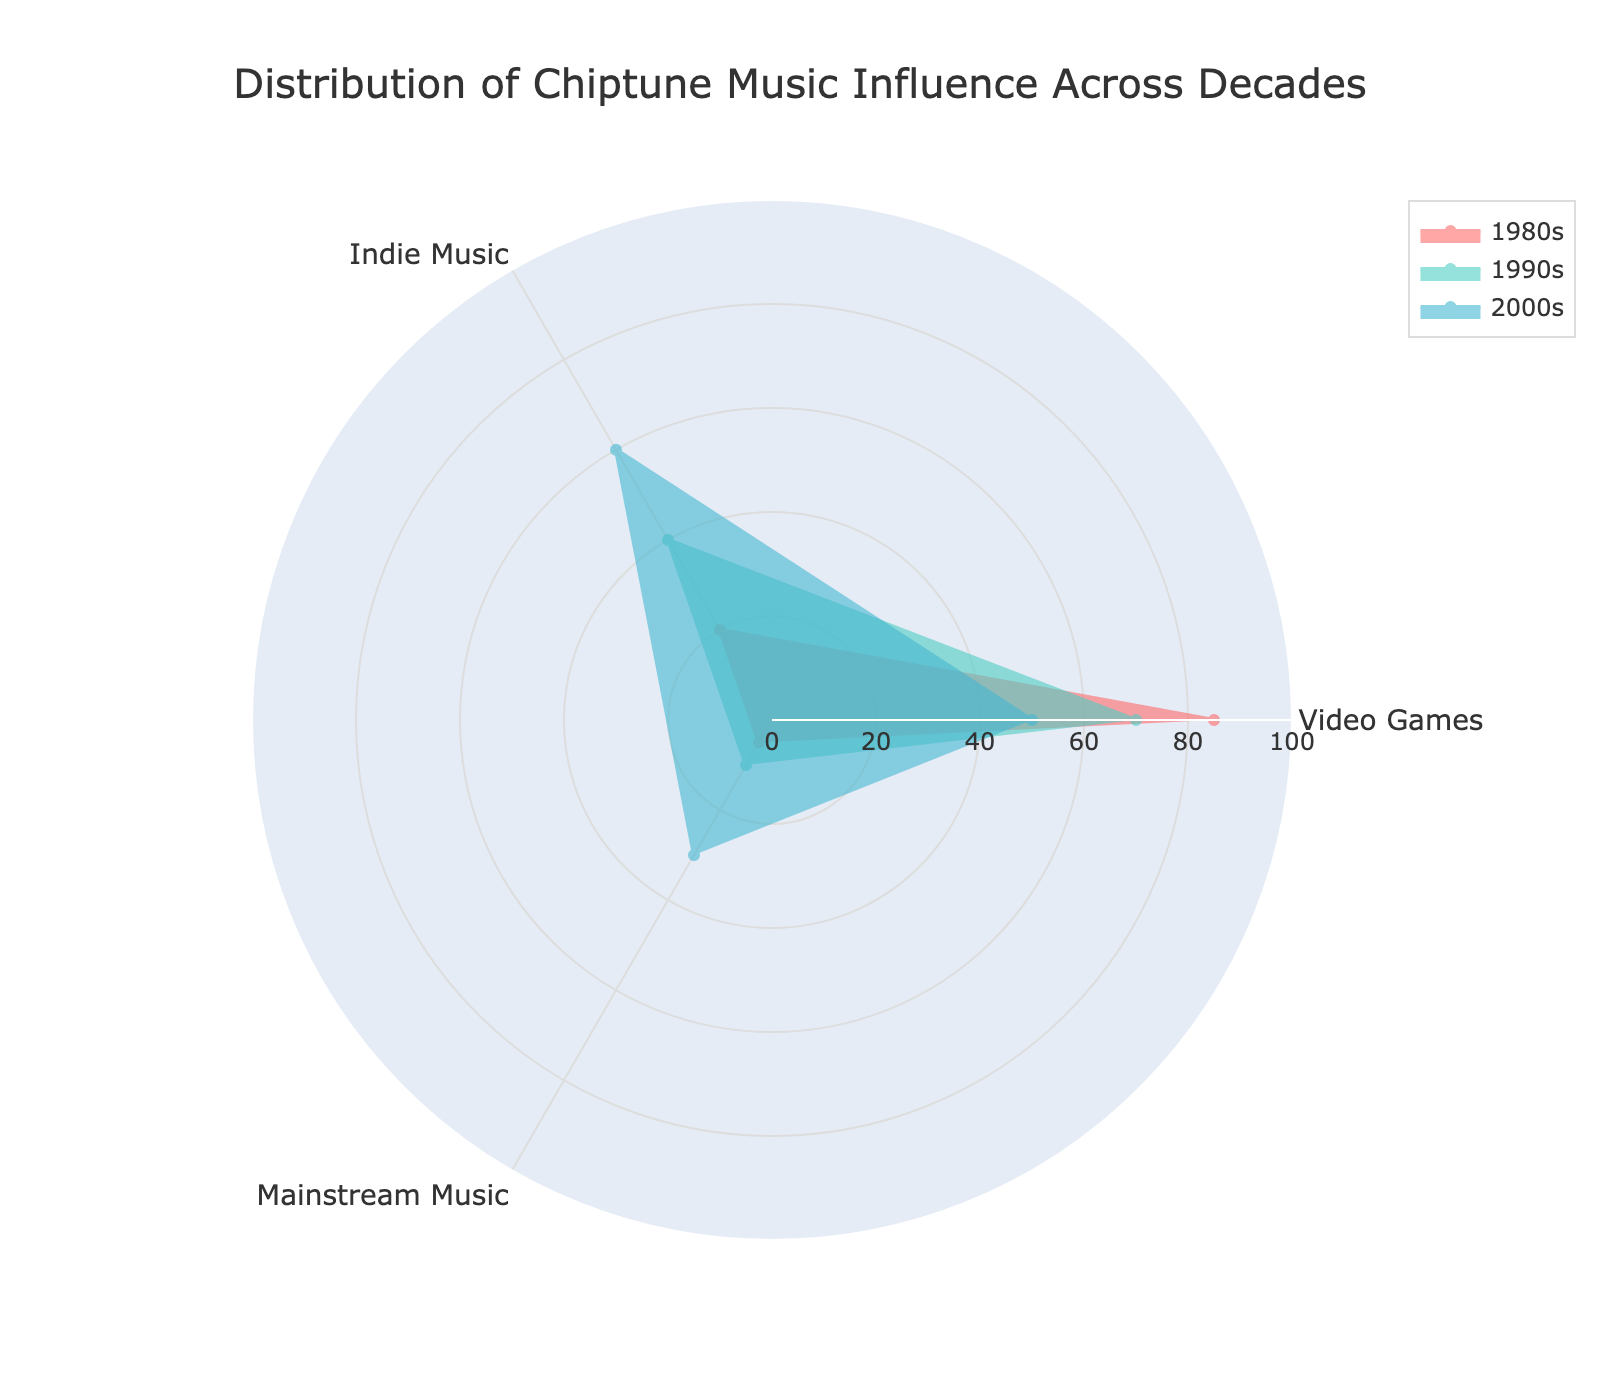What is the title of the radar chart? The title of the radar chart is usually located at the top of the chart, within the layout section. In this radar chart, it is specified as 'Distribution of Chiptune Music Influence Across Decades' as mentioned in the provided code.
Answer: Distribution of Chiptune Music Influence Across Decades Which decade shows the highest influence in Video Games? To determine the highest influence, compare the data points for Video Games across all decades. The 1980s have a value of 85, the 1990s have 70, and the 2000s have 50. The highest value is in the 1980s.
Answer: 1980s How does the influence of chiptune in Indie Music change from the 1980s to the 2000s? Examine the data points for Indie Music across the decades. The values are 20 in the 1980s, 40 in the 1990s, and 60 in the 2000s. The value increases over time.
Answer: It increases Which category shows the most significant change between the 1980s and 2000s? Calculate the difference for each category between the 1980s and 2000s: 
Video Games: 85 - 50 = 35
Indie Music: 60 - 20 = 40
Mainstream Music: 30 - 5 = 25
The most significant change is in Indie Music (40).
Answer: Indie Music What is the combined influence of chiptune in Mainstream Music for all decades? Add the values of Mainstream Music across all decades: 
1980s: 5, 
1990s: 10, 
2000s: 30. 
Total = 5 + 10 + 30 = 45.
Answer: 45 Which decade has the least influence on Mainstream Music? Compare the values for Mainstream Music over the decades. The 1980s have 5, the 1990s have 10, and the 2000s have 30. The least value is in the 1980s.
Answer: 1980s How does the influence on Indie Music in the 1990s compare to that on Mainstream Music in the same decade? Check the values for Indie Music and Mainstream Music in the 1990s. Indie Music has a value of 40, while Mainstream Music has 10. Indie Music has a higher value.
Answer: Indie Music is higher What is the average influence across all categories in the 1980s? Calculate the average of the values for the 1980s across all categories: 
Video Games: 85, 
Indie Music: 20, 
Mainstream Music: 5. 
Average = (85 + 20 + 5) / 3 ≈ 36.67.
Answer: 36.67 Which category shows the least influence across all decades combined? Sum up the values for each category across all decades: 
Video Games: 85 + 70 + 50 = 205, 
Indie Music: 20 + 40 + 60 = 120, 
Mainstream Music: 5 + 10 + 30 = 45. 
The least influence is in Mainstream Music.
Answer: Mainstream Music Which category has the most consistent influence across the decades? Determine the variability by examining the range of values for each category:
Video Games: Max 85, Min 50, Range = 35
Indie Music: Max 60, Min 20, Range = 40
Mainstream Music: Max 30, Min 5, Range = 25
Mainstream Music has the smallest range, indicating the most consistent influence.
Answer: Mainstream Music 